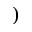<formula> <loc_0><loc_0><loc_500><loc_500>)</formula> 